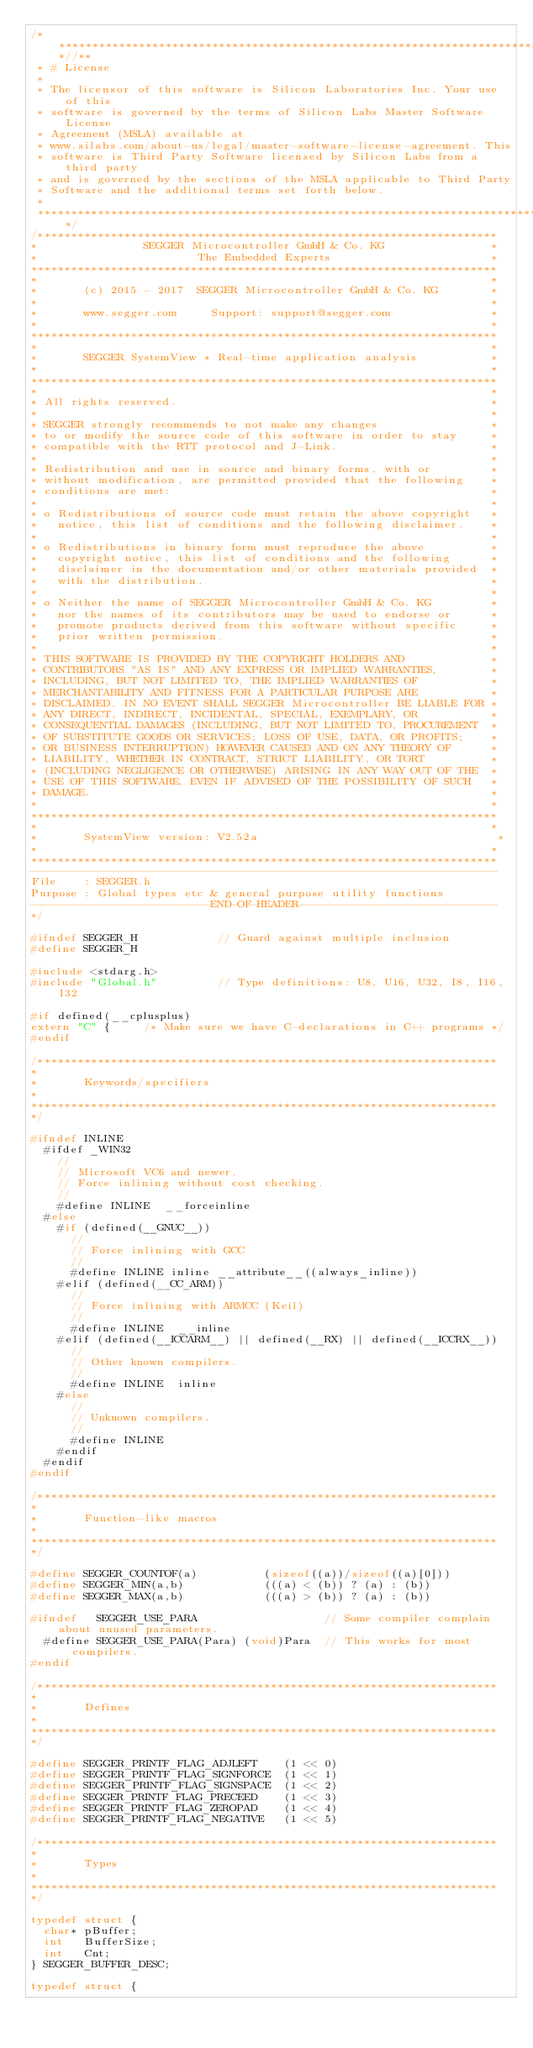<code> <loc_0><loc_0><loc_500><loc_500><_C_>/***************************************************************************//**
 * # License
 *
 * The licensor of this software is Silicon Laboratories Inc. Your use of this
 * software is governed by the terms of Silicon Labs Master Software License
 * Agreement (MSLA) available at
 * www.silabs.com/about-us/legal/master-software-license-agreement. This
 * software is Third Party Software licensed by Silicon Labs from a third party
 * and is governed by the sections of the MSLA applicable to Third Party
 * Software and the additional terms set forth below.
 *
 ******************************************************************************/
/*********************************************************************
*                SEGGER Microcontroller GmbH & Co. KG                *
*                        The Embedded Experts                        *
**********************************************************************
*                                                                    *
*       (c) 2015 - 2017  SEGGER Microcontroller GmbH & Co. KG        *
*                                                                    *
*       www.segger.com     Support: support@segger.com               *
*                                                                    *
**********************************************************************
*                                                                    *
*       SEGGER SystemView * Real-time application analysis           *
*                                                                    *
**********************************************************************
*                                                                    *
* All rights reserved.                                               *
*                                                                    *
* SEGGER strongly recommends to not make any changes                 *
* to or modify the source code of this software in order to stay     *
* compatible with the RTT protocol and J-Link.                       *
*                                                                    *
* Redistribution and use in source and binary forms, with or         *
* without modification, are permitted provided that the following    *
* conditions are met:                                                *
*                                                                    *
* o Redistributions of source code must retain the above copyright   *
*   notice, this list of conditions and the following disclaimer.    *
*                                                                    *
* o Redistributions in binary form must reproduce the above          *
*   copyright notice, this list of conditions and the following      *
*   disclaimer in the documentation and/or other materials provided  *
*   with the distribution.                                           *
*                                                                    *
* o Neither the name of SEGGER Microcontroller GmbH & Co. KG         *
*   nor the names of its contributors may be used to endorse or      *
*   promote products derived from this software without specific     *
*   prior written permission.                                        *
*                                                                    *
* THIS SOFTWARE IS PROVIDED BY THE COPYRIGHT HOLDERS AND             *
* CONTRIBUTORS "AS IS" AND ANY EXPRESS OR IMPLIED WARRANTIES,        *
* INCLUDING, BUT NOT LIMITED TO, THE IMPLIED WARRANTIES OF           *
* MERCHANTABILITY AND FITNESS FOR A PARTICULAR PURPOSE ARE           *
* DISCLAIMED. IN NO EVENT SHALL SEGGER Microcontroller BE LIABLE FOR *
* ANY DIRECT, INDIRECT, INCIDENTAL, SPECIAL, EXEMPLARY, OR           *
* CONSEQUENTIAL DAMAGES (INCLUDING, BUT NOT LIMITED TO, PROCUREMENT  *
* OF SUBSTITUTE GOODS OR SERVICES; LOSS OF USE, DATA, OR PROFITS;    *
* OR BUSINESS INTERRUPTION) HOWEVER CAUSED AND ON ANY THEORY OF      *
* LIABILITY, WHETHER IN CONTRACT, STRICT LIABILITY, OR TORT          *
* (INCLUDING NEGLIGENCE OR OTHERWISE) ARISING IN ANY WAY OUT OF THE  *
* USE OF THIS SOFTWARE, EVEN IF ADVISED OF THE POSSIBILITY OF SUCH   *
* DAMAGE.                                                            *
*                                                                    *
**********************************************************************
*                                                                    *
*       SystemView version: V2.52a                                    *
*                                                                    *
**********************************************************************
----------------------------------------------------------------------
File    : SEGGER.h
Purpose : Global types etc & general purpose utility functions
---------------------------END-OF-HEADER------------------------------
*/

#ifndef SEGGER_H            // Guard against multiple inclusion
#define SEGGER_H

#include <stdarg.h>
#include "Global.h"         // Type definitions: U8, U16, U32, I8, I16, I32

#if defined(__cplusplus)
extern "C" {     /* Make sure we have C-declarations in C++ programs */
#endif

/*********************************************************************
*
*       Keywords/specifiers
*
**********************************************************************
*/

#ifndef INLINE
  #ifdef _WIN32
    //
    // Microsoft VC6 and newer.
    // Force inlining without cost checking.
    //
    #define INLINE  __forceinline
  #else
    #if (defined(__GNUC__))
      //
      // Force inlining with GCC
      //
      #define INLINE inline __attribute__((always_inline))
    #elif (defined(__CC_ARM))
      //
      // Force inlining with ARMCC (Keil)
      //
      #define INLINE  __inline
    #elif (defined(__ICCARM__) || defined(__RX) || defined(__ICCRX__))
      //
      // Other known compilers.
      //
      #define INLINE  inline
    #else
      //
      // Unknown compilers.
      //
      #define INLINE
    #endif
  #endif
#endif

/*********************************************************************
*
*       Function-like macros
*
**********************************************************************
*/

#define SEGGER_COUNTOF(a)          (sizeof((a))/sizeof((a)[0]))
#define SEGGER_MIN(a,b)            (((a) < (b)) ? (a) : (b))
#define SEGGER_MAX(a,b)            (((a) > (b)) ? (a) : (b))

#ifndef   SEGGER_USE_PARA                   // Some compiler complain about unused parameters.
  #define SEGGER_USE_PARA(Para) (void)Para  // This works for most compilers.
#endif

/*********************************************************************
*
*       Defines
*
**********************************************************************
*/

#define SEGGER_PRINTF_FLAG_ADJLEFT    (1 << 0)
#define SEGGER_PRINTF_FLAG_SIGNFORCE  (1 << 1)
#define SEGGER_PRINTF_FLAG_SIGNSPACE  (1 << 2)
#define SEGGER_PRINTF_FLAG_PRECEED    (1 << 3)
#define SEGGER_PRINTF_FLAG_ZEROPAD    (1 << 4)
#define SEGGER_PRINTF_FLAG_NEGATIVE   (1 << 5)

/*********************************************************************
*
*       Types
*
**********************************************************************
*/

typedef struct {
  char* pBuffer;
  int   BufferSize;
  int   Cnt;
} SEGGER_BUFFER_DESC;

typedef struct {</code> 